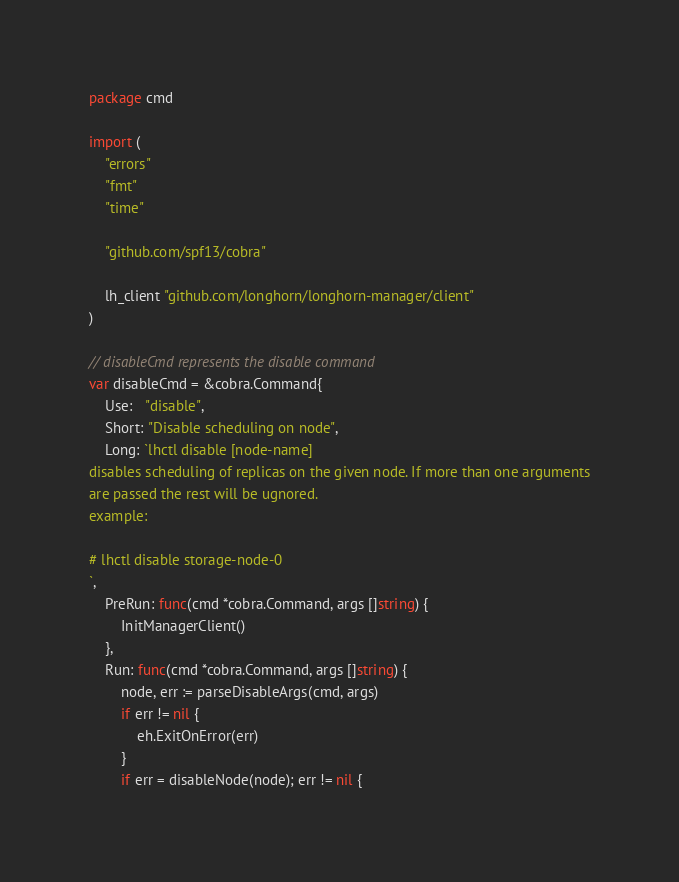Convert code to text. <code><loc_0><loc_0><loc_500><loc_500><_Go_>package cmd

import (
	"errors"
	"fmt"
	"time"

	"github.com/spf13/cobra"

	lh_client "github.com/longhorn/longhorn-manager/client"
)

// disableCmd represents the disable command
var disableCmd = &cobra.Command{
	Use:   "disable",
	Short: "Disable scheduling on node",
	Long: `lhctl disable [node-name]
disables scheduling of replicas on the given node. If more than one arguments
are passed the rest will be ugnored.
example:

# lhctl disable storage-node-0
`,
	PreRun: func(cmd *cobra.Command, args []string) {
		InitManagerClient()
	},
	Run: func(cmd *cobra.Command, args []string) {
		node, err := parseDisableArgs(cmd, args)
		if err != nil {
			eh.ExitOnError(err)
		}
		if err = disableNode(node); err != nil {</code> 